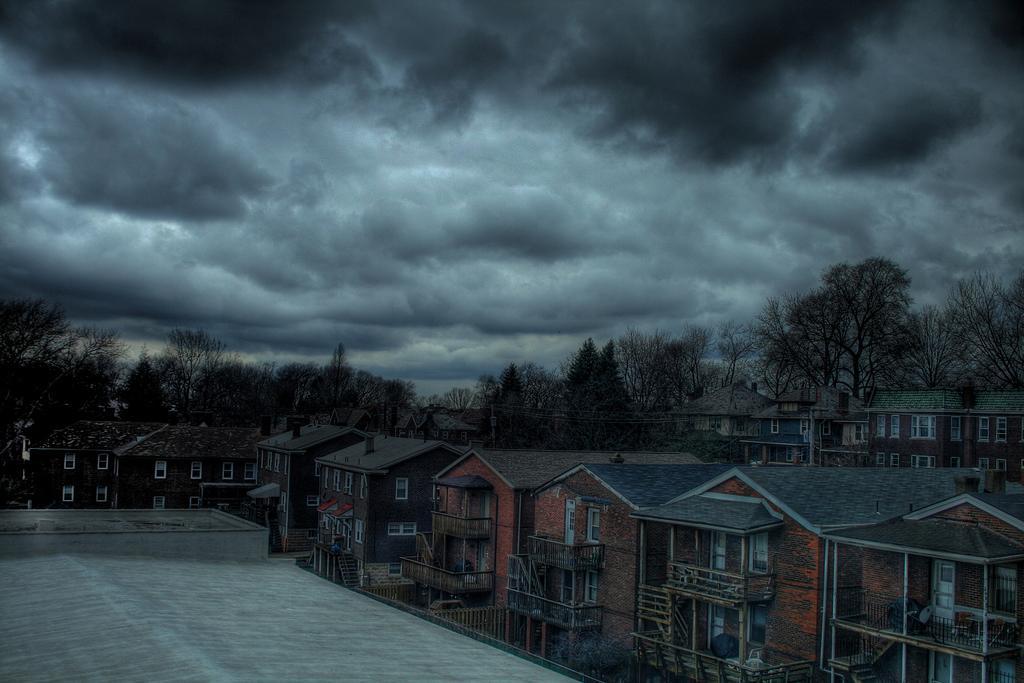Could you give a brief overview of what you see in this image? In the image there are buildings with walls, windows, roofs, chimneys, poles and railings. In the background there are trees. At the top of the image there is sky with clouds. 